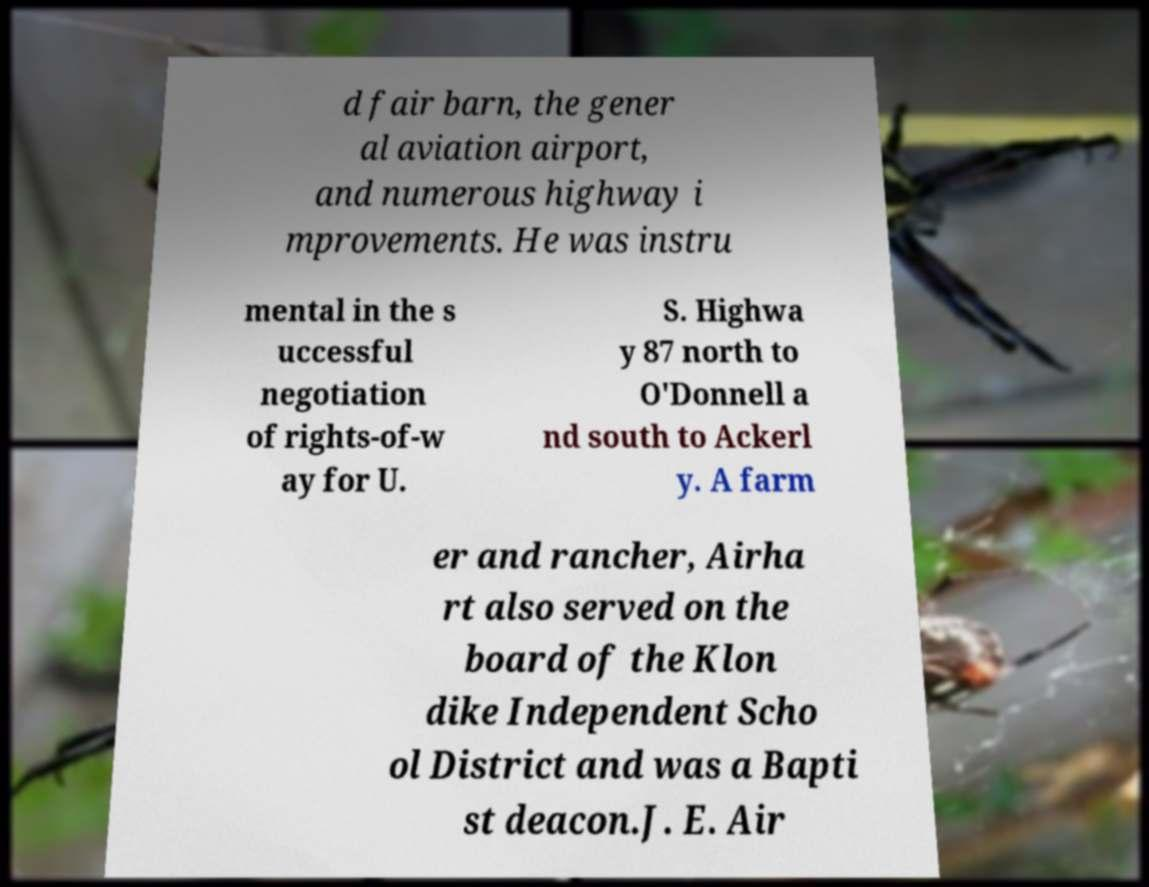What messages or text are displayed in this image? I need them in a readable, typed format. d fair barn, the gener al aviation airport, and numerous highway i mprovements. He was instru mental in the s uccessful negotiation of rights-of-w ay for U. S. Highwa y 87 north to O'Donnell a nd south to Ackerl y. A farm er and rancher, Airha rt also served on the board of the Klon dike Independent Scho ol District and was a Bapti st deacon.J. E. Air 